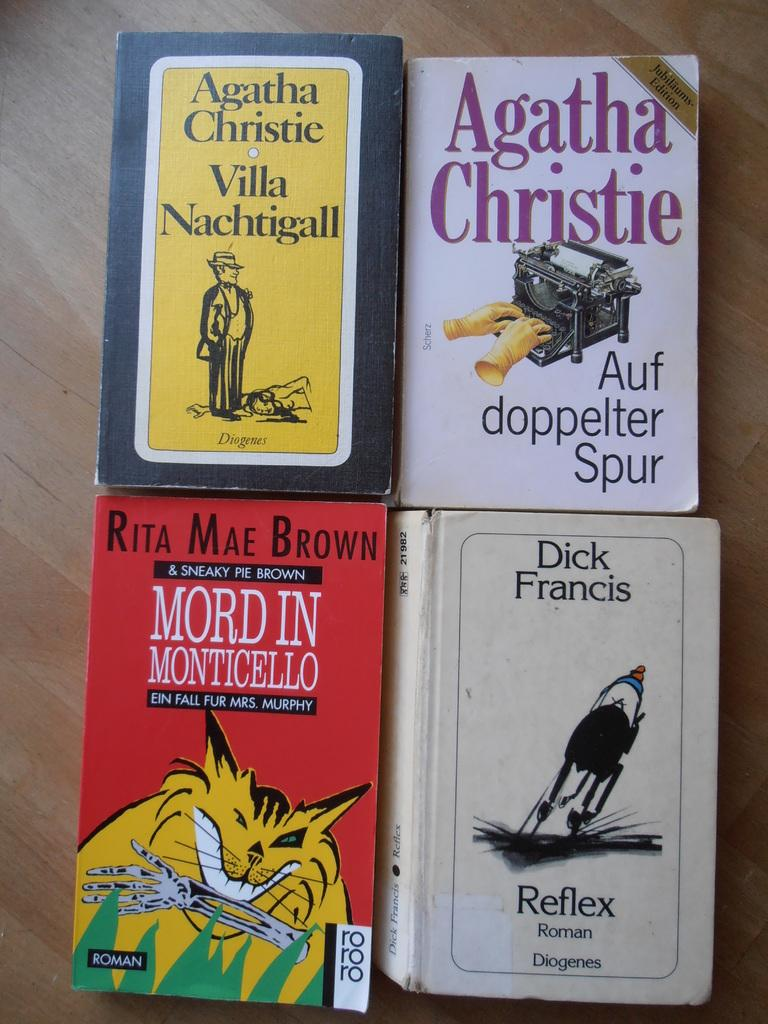Provide a one-sentence caption for the provided image. Four mystery, including two Agathy Christie, novels presented on a wooden table. 